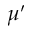<formula> <loc_0><loc_0><loc_500><loc_500>\mu ^ { \prime }</formula> 